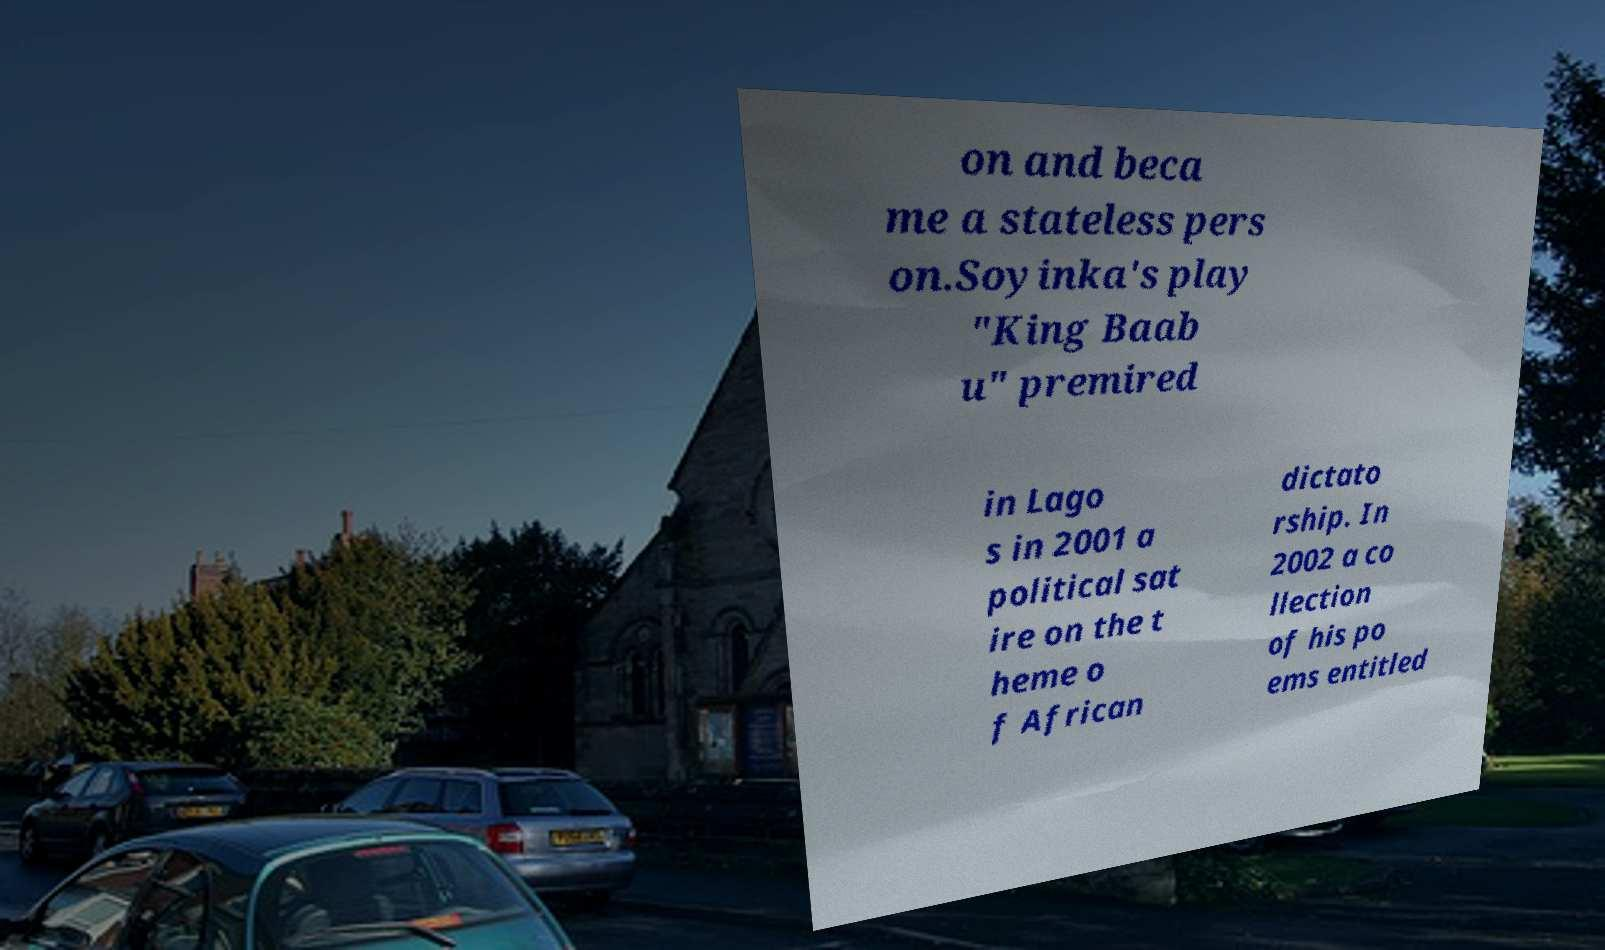I need the written content from this picture converted into text. Can you do that? on and beca me a stateless pers on.Soyinka's play "King Baab u" premired in Lago s in 2001 a political sat ire on the t heme o f African dictato rship. In 2002 a co llection of his po ems entitled 